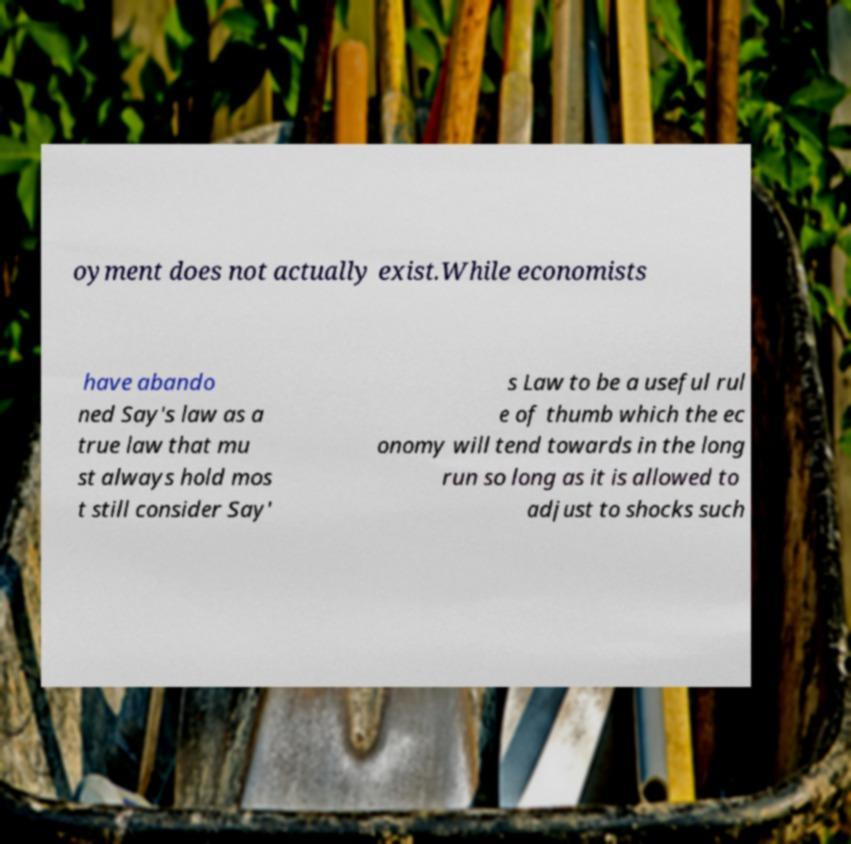Can you read and provide the text displayed in the image?This photo seems to have some interesting text. Can you extract and type it out for me? oyment does not actually exist.While economists have abando ned Say's law as a true law that mu st always hold mos t still consider Say' s Law to be a useful rul e of thumb which the ec onomy will tend towards in the long run so long as it is allowed to adjust to shocks such 